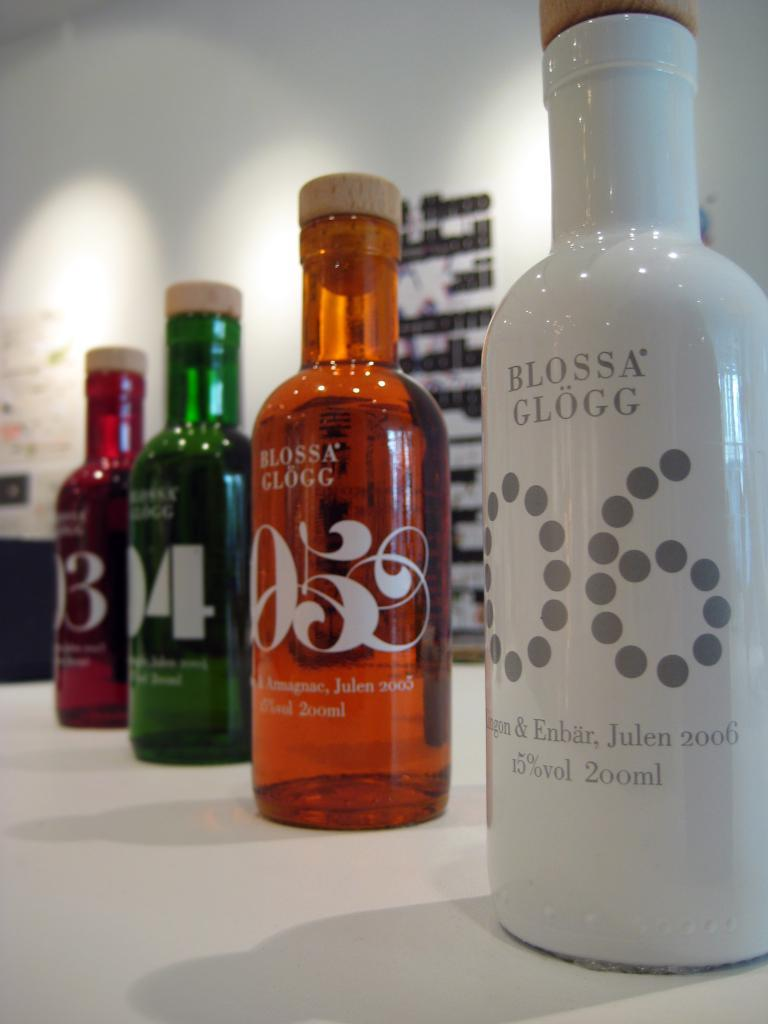How many bottles are visible in the image? There are four bottles in the image. Where are the bottles located? The bottles are on a table. What language is spoken by the laborer in the image? There is no laborer present in the image, so it is not possible to determine what language they might speak. What type of pie is being served on a plate in the image? There is no pie present in the image. 